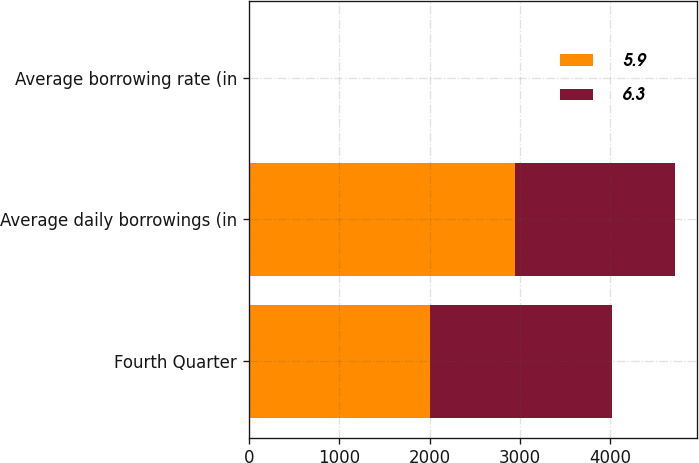<chart> <loc_0><loc_0><loc_500><loc_500><stacked_bar_chart><ecel><fcel>Fourth Quarter<fcel>Average daily borrowings (in<fcel>Average borrowing rate (in<nl><fcel>5.9<fcel>2007<fcel>2943<fcel>6.3<nl><fcel>6.3<fcel>2006<fcel>1776<fcel>5.9<nl></chart> 